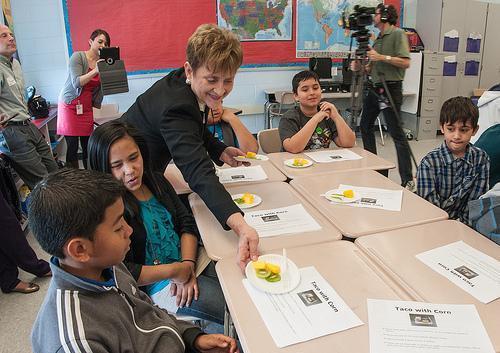How many women are bending?
Give a very brief answer. 1. 